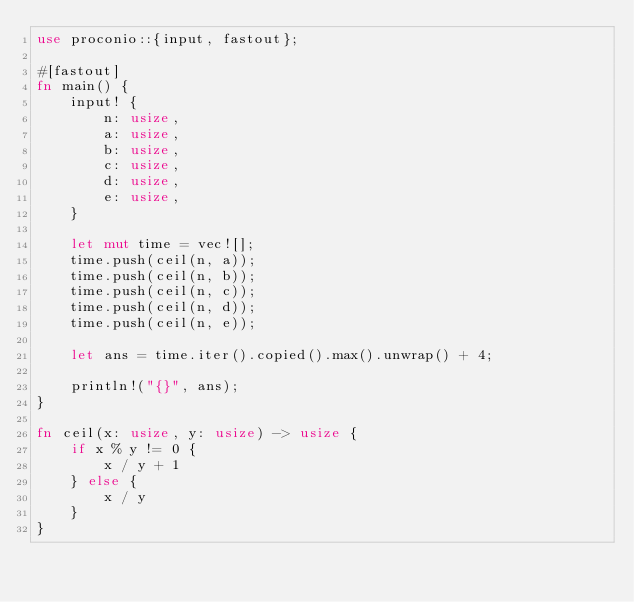Convert code to text. <code><loc_0><loc_0><loc_500><loc_500><_Rust_>use proconio::{input, fastout};

#[fastout]
fn main() {
    input! {
        n: usize,
        a: usize,
        b: usize,
        c: usize,
        d: usize,
        e: usize,
    }

    let mut time = vec![];
    time.push(ceil(n, a));
    time.push(ceil(n, b));
    time.push(ceil(n, c));
    time.push(ceil(n, d));
    time.push(ceil(n, e));

    let ans = time.iter().copied().max().unwrap() + 4;

    println!("{}", ans);
}

fn ceil(x: usize, y: usize) -> usize {
    if x % y != 0 {
        x / y + 1
    } else {
        x / y
    }
}</code> 